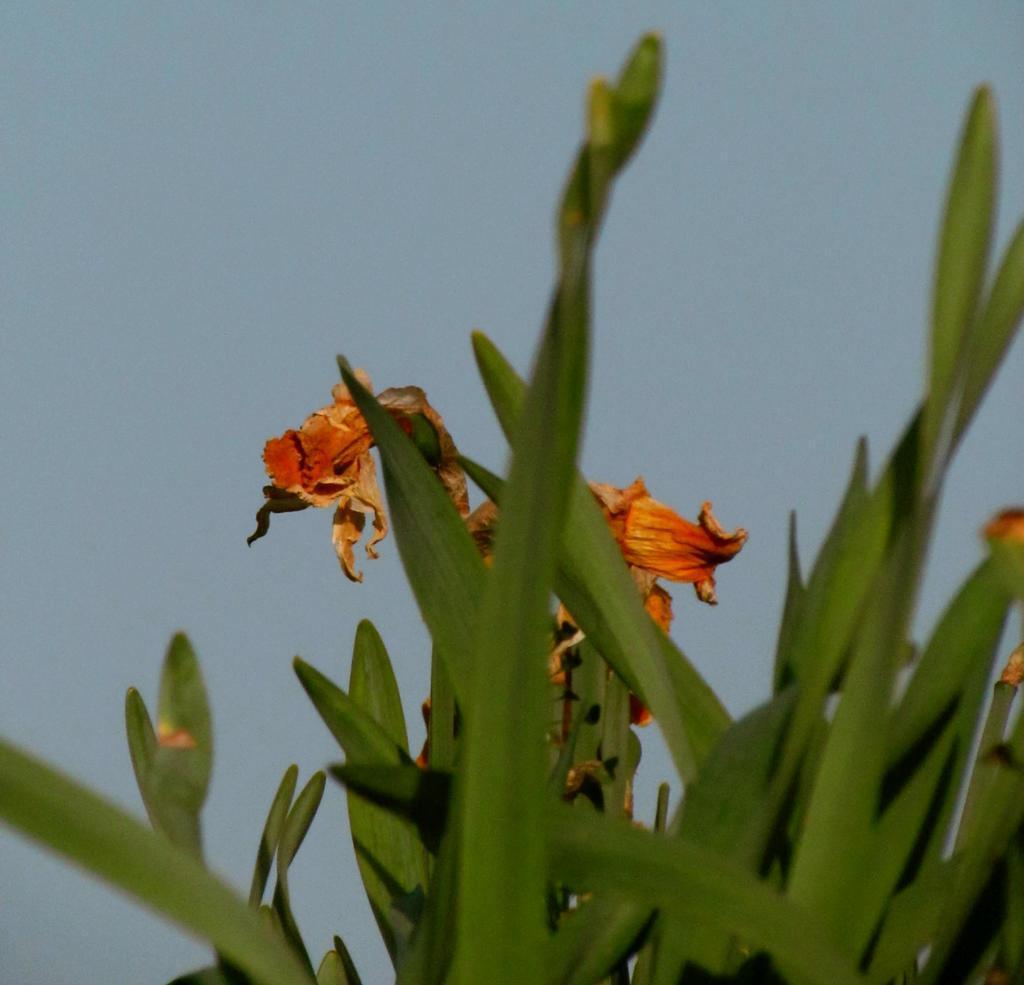In one or two sentences, can you explain what this image depicts? In this image I can see a plant which is green in color and a flower to the plant which is orange in color. In the background I can see the sky. 